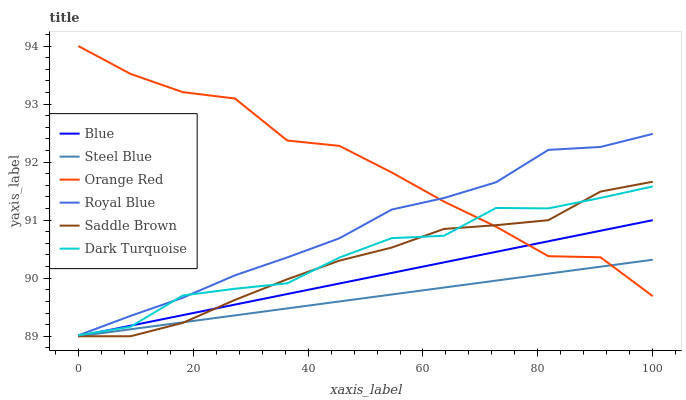Does Steel Blue have the minimum area under the curve?
Answer yes or no. Yes. Does Orange Red have the maximum area under the curve?
Answer yes or no. Yes. Does Dark Turquoise have the minimum area under the curve?
Answer yes or no. No. Does Dark Turquoise have the maximum area under the curve?
Answer yes or no. No. Is Steel Blue the smoothest?
Answer yes or no. Yes. Is Orange Red the roughest?
Answer yes or no. Yes. Is Dark Turquoise the smoothest?
Answer yes or no. No. Is Dark Turquoise the roughest?
Answer yes or no. No. Does Blue have the lowest value?
Answer yes or no. Yes. Does Dark Turquoise have the lowest value?
Answer yes or no. No. Does Orange Red have the highest value?
Answer yes or no. Yes. Does Dark Turquoise have the highest value?
Answer yes or no. No. Is Steel Blue less than Dark Turquoise?
Answer yes or no. Yes. Is Dark Turquoise greater than Steel Blue?
Answer yes or no. Yes. Does Blue intersect Dark Turquoise?
Answer yes or no. Yes. Is Blue less than Dark Turquoise?
Answer yes or no. No. Is Blue greater than Dark Turquoise?
Answer yes or no. No. Does Steel Blue intersect Dark Turquoise?
Answer yes or no. No. 